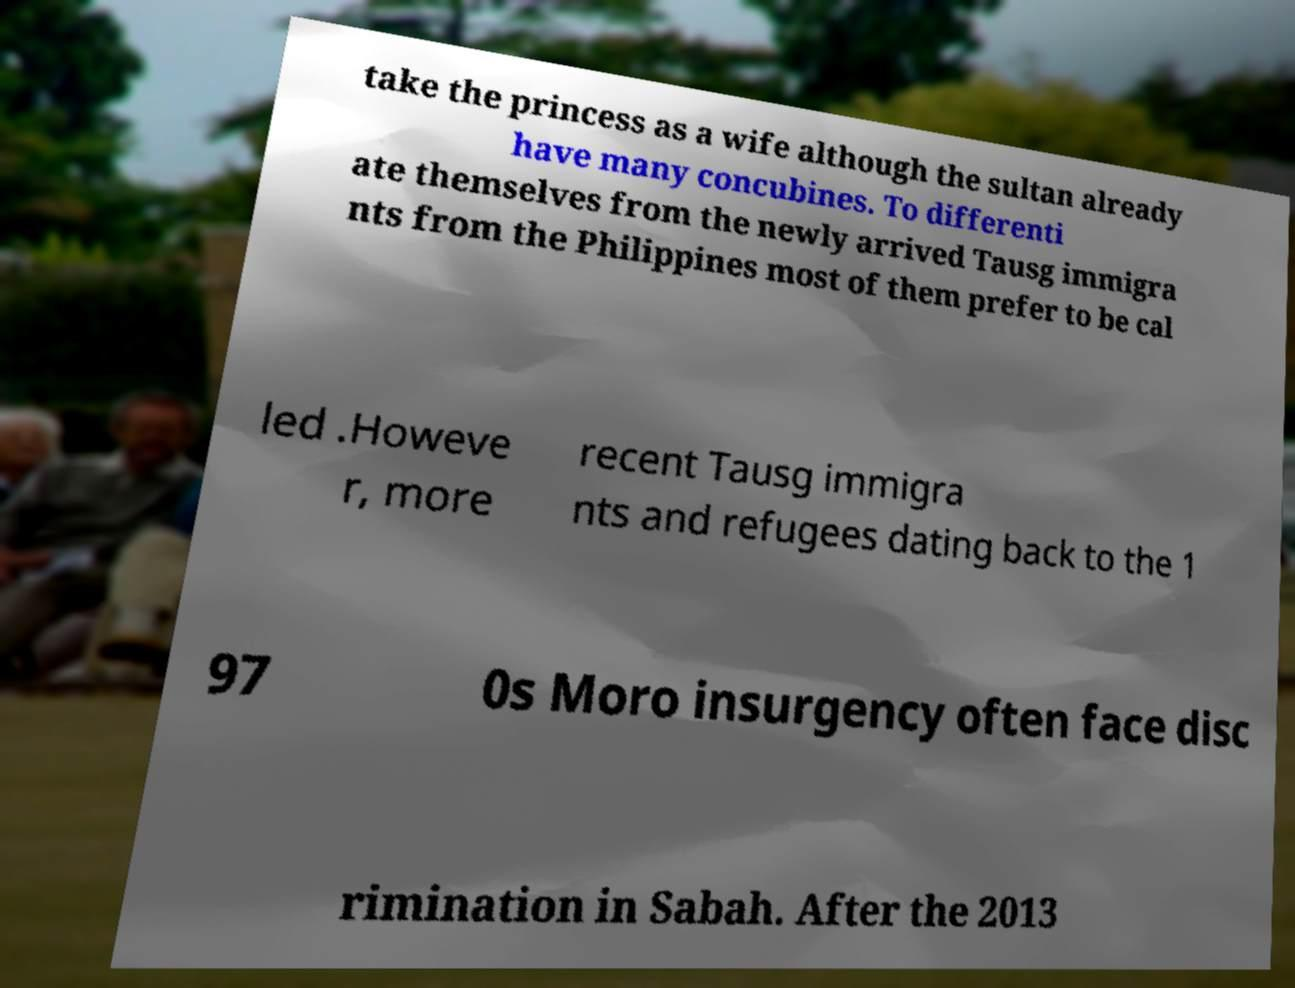There's text embedded in this image that I need extracted. Can you transcribe it verbatim? take the princess as a wife although the sultan already have many concubines. To differenti ate themselves from the newly arrived Tausg immigra nts from the Philippines most of them prefer to be cal led .Howeve r, more recent Tausg immigra nts and refugees dating back to the 1 97 0s Moro insurgency often face disc rimination in Sabah. After the 2013 